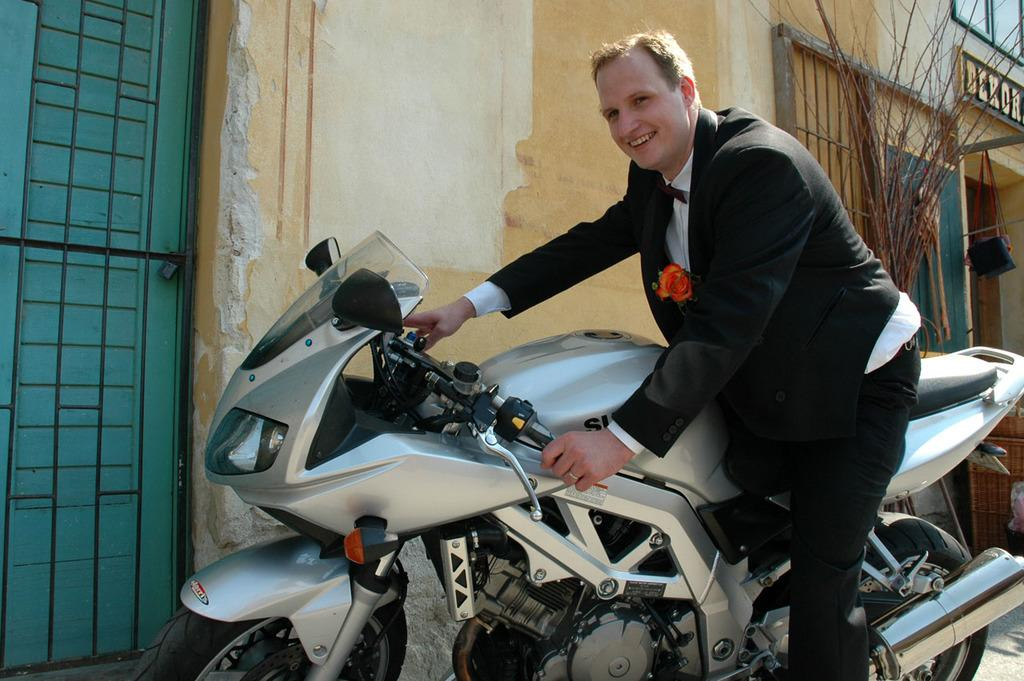What is the main subject in the middle of the image? There is a bike in the middle of the image. Who is on the bike? A man is on the bike. What is the man wearing? The man is wearing a suit, trousers, and a white shirt. What is the man's facial expression? The man is smiling. What can be seen in the background of the image? There is a wall, a door, a plant, and text in the background of the image. What type of magic is the man performing on the bike? There is no indication of magic or any magical activity in the image. What army is the man associated with in the image? There is no reference to an army or any military affiliation in the image. 